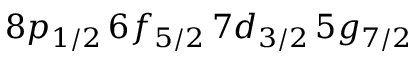Convert formula to latex. <formula><loc_0><loc_0><loc_500><loc_500>8 p _ { 1 / 2 } \, 6 f _ { 5 / 2 } \, 7 d _ { 3 / 2 } \, 5 g _ { 7 / 2 }</formula> 